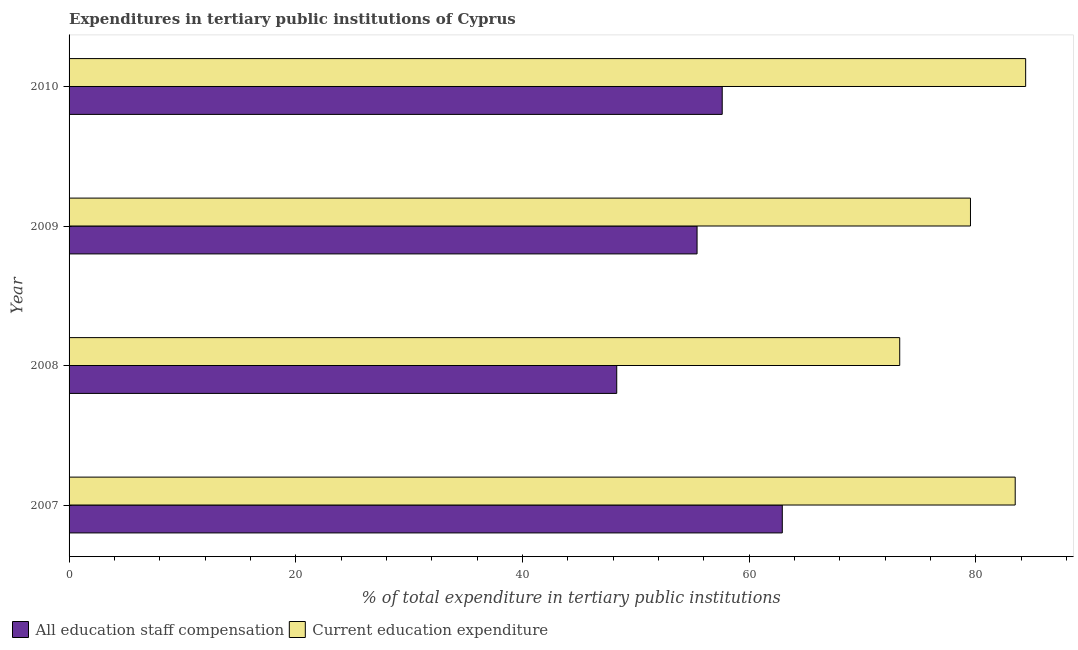How many different coloured bars are there?
Offer a terse response. 2. How many bars are there on the 3rd tick from the bottom?
Make the answer very short. 2. What is the label of the 1st group of bars from the top?
Ensure brevity in your answer.  2010. What is the expenditure in education in 2010?
Keep it short and to the point. 84.39. Across all years, what is the maximum expenditure in education?
Keep it short and to the point. 84.39. Across all years, what is the minimum expenditure in staff compensation?
Make the answer very short. 48.31. In which year was the expenditure in education minimum?
Offer a terse response. 2008. What is the total expenditure in staff compensation in the graph?
Your answer should be compact. 224.26. What is the difference between the expenditure in staff compensation in 2009 and that in 2010?
Your answer should be very brief. -2.22. What is the difference between the expenditure in education in 2008 and the expenditure in staff compensation in 2010?
Your response must be concise. 15.66. What is the average expenditure in staff compensation per year?
Make the answer very short. 56.06. In the year 2007, what is the difference between the expenditure in education and expenditure in staff compensation?
Provide a succinct answer. 20.55. What is the ratio of the expenditure in staff compensation in 2007 to that in 2010?
Offer a terse response. 1.09. Is the expenditure in education in 2008 less than that in 2010?
Your response must be concise. Yes. What is the difference between the highest and the second highest expenditure in staff compensation?
Your answer should be compact. 5.3. What is the difference between the highest and the lowest expenditure in education?
Offer a terse response. 11.11. Is the sum of the expenditure in education in 2009 and 2010 greater than the maximum expenditure in staff compensation across all years?
Your answer should be very brief. Yes. What does the 1st bar from the top in 2010 represents?
Your response must be concise. Current education expenditure. What does the 1st bar from the bottom in 2008 represents?
Offer a terse response. All education staff compensation. How many bars are there?
Your response must be concise. 8. How many years are there in the graph?
Provide a short and direct response. 4. Does the graph contain any zero values?
Provide a short and direct response. No. Does the graph contain grids?
Give a very brief answer. No. Where does the legend appear in the graph?
Give a very brief answer. Bottom left. How many legend labels are there?
Ensure brevity in your answer.  2. What is the title of the graph?
Provide a succinct answer. Expenditures in tertiary public institutions of Cyprus. What is the label or title of the X-axis?
Ensure brevity in your answer.  % of total expenditure in tertiary public institutions. What is the % of total expenditure in tertiary public institutions in All education staff compensation in 2007?
Ensure brevity in your answer.  62.92. What is the % of total expenditure in tertiary public institutions in Current education expenditure in 2007?
Your answer should be very brief. 83.47. What is the % of total expenditure in tertiary public institutions of All education staff compensation in 2008?
Your answer should be compact. 48.31. What is the % of total expenditure in tertiary public institutions in Current education expenditure in 2008?
Your answer should be compact. 73.28. What is the % of total expenditure in tertiary public institutions of All education staff compensation in 2009?
Ensure brevity in your answer.  55.4. What is the % of total expenditure in tertiary public institutions in Current education expenditure in 2009?
Ensure brevity in your answer.  79.52. What is the % of total expenditure in tertiary public institutions in All education staff compensation in 2010?
Your answer should be compact. 57.62. What is the % of total expenditure in tertiary public institutions in Current education expenditure in 2010?
Your response must be concise. 84.39. Across all years, what is the maximum % of total expenditure in tertiary public institutions of All education staff compensation?
Your answer should be very brief. 62.92. Across all years, what is the maximum % of total expenditure in tertiary public institutions of Current education expenditure?
Provide a short and direct response. 84.39. Across all years, what is the minimum % of total expenditure in tertiary public institutions in All education staff compensation?
Give a very brief answer. 48.31. Across all years, what is the minimum % of total expenditure in tertiary public institutions in Current education expenditure?
Your response must be concise. 73.28. What is the total % of total expenditure in tertiary public institutions in All education staff compensation in the graph?
Give a very brief answer. 224.26. What is the total % of total expenditure in tertiary public institutions of Current education expenditure in the graph?
Ensure brevity in your answer.  320.66. What is the difference between the % of total expenditure in tertiary public institutions of All education staff compensation in 2007 and that in 2008?
Provide a short and direct response. 14.61. What is the difference between the % of total expenditure in tertiary public institutions in Current education expenditure in 2007 and that in 2008?
Your response must be concise. 10.19. What is the difference between the % of total expenditure in tertiary public institutions of All education staff compensation in 2007 and that in 2009?
Offer a very short reply. 7.52. What is the difference between the % of total expenditure in tertiary public institutions of Current education expenditure in 2007 and that in 2009?
Your response must be concise. 3.95. What is the difference between the % of total expenditure in tertiary public institutions of All education staff compensation in 2007 and that in 2010?
Your response must be concise. 5.3. What is the difference between the % of total expenditure in tertiary public institutions of Current education expenditure in 2007 and that in 2010?
Your response must be concise. -0.92. What is the difference between the % of total expenditure in tertiary public institutions in All education staff compensation in 2008 and that in 2009?
Make the answer very short. -7.09. What is the difference between the % of total expenditure in tertiary public institutions in Current education expenditure in 2008 and that in 2009?
Provide a short and direct response. -6.24. What is the difference between the % of total expenditure in tertiary public institutions in All education staff compensation in 2008 and that in 2010?
Your response must be concise. -9.31. What is the difference between the % of total expenditure in tertiary public institutions in Current education expenditure in 2008 and that in 2010?
Provide a short and direct response. -11.11. What is the difference between the % of total expenditure in tertiary public institutions in All education staff compensation in 2009 and that in 2010?
Offer a very short reply. -2.22. What is the difference between the % of total expenditure in tertiary public institutions of Current education expenditure in 2009 and that in 2010?
Your answer should be compact. -4.87. What is the difference between the % of total expenditure in tertiary public institutions in All education staff compensation in 2007 and the % of total expenditure in tertiary public institutions in Current education expenditure in 2008?
Make the answer very short. -10.36. What is the difference between the % of total expenditure in tertiary public institutions of All education staff compensation in 2007 and the % of total expenditure in tertiary public institutions of Current education expenditure in 2009?
Keep it short and to the point. -16.6. What is the difference between the % of total expenditure in tertiary public institutions of All education staff compensation in 2007 and the % of total expenditure in tertiary public institutions of Current education expenditure in 2010?
Make the answer very short. -21.47. What is the difference between the % of total expenditure in tertiary public institutions of All education staff compensation in 2008 and the % of total expenditure in tertiary public institutions of Current education expenditure in 2009?
Keep it short and to the point. -31.21. What is the difference between the % of total expenditure in tertiary public institutions in All education staff compensation in 2008 and the % of total expenditure in tertiary public institutions in Current education expenditure in 2010?
Make the answer very short. -36.08. What is the difference between the % of total expenditure in tertiary public institutions in All education staff compensation in 2009 and the % of total expenditure in tertiary public institutions in Current education expenditure in 2010?
Provide a short and direct response. -28.99. What is the average % of total expenditure in tertiary public institutions of All education staff compensation per year?
Ensure brevity in your answer.  56.06. What is the average % of total expenditure in tertiary public institutions of Current education expenditure per year?
Provide a short and direct response. 80.16. In the year 2007, what is the difference between the % of total expenditure in tertiary public institutions of All education staff compensation and % of total expenditure in tertiary public institutions of Current education expenditure?
Offer a very short reply. -20.55. In the year 2008, what is the difference between the % of total expenditure in tertiary public institutions of All education staff compensation and % of total expenditure in tertiary public institutions of Current education expenditure?
Keep it short and to the point. -24.97. In the year 2009, what is the difference between the % of total expenditure in tertiary public institutions of All education staff compensation and % of total expenditure in tertiary public institutions of Current education expenditure?
Your answer should be very brief. -24.12. In the year 2010, what is the difference between the % of total expenditure in tertiary public institutions in All education staff compensation and % of total expenditure in tertiary public institutions in Current education expenditure?
Your response must be concise. -26.77. What is the ratio of the % of total expenditure in tertiary public institutions of All education staff compensation in 2007 to that in 2008?
Your response must be concise. 1.3. What is the ratio of the % of total expenditure in tertiary public institutions of Current education expenditure in 2007 to that in 2008?
Offer a terse response. 1.14. What is the ratio of the % of total expenditure in tertiary public institutions of All education staff compensation in 2007 to that in 2009?
Your answer should be very brief. 1.14. What is the ratio of the % of total expenditure in tertiary public institutions of Current education expenditure in 2007 to that in 2009?
Your answer should be very brief. 1.05. What is the ratio of the % of total expenditure in tertiary public institutions in All education staff compensation in 2007 to that in 2010?
Your response must be concise. 1.09. What is the ratio of the % of total expenditure in tertiary public institutions of All education staff compensation in 2008 to that in 2009?
Make the answer very short. 0.87. What is the ratio of the % of total expenditure in tertiary public institutions of Current education expenditure in 2008 to that in 2009?
Offer a terse response. 0.92. What is the ratio of the % of total expenditure in tertiary public institutions of All education staff compensation in 2008 to that in 2010?
Your answer should be compact. 0.84. What is the ratio of the % of total expenditure in tertiary public institutions in Current education expenditure in 2008 to that in 2010?
Ensure brevity in your answer.  0.87. What is the ratio of the % of total expenditure in tertiary public institutions of All education staff compensation in 2009 to that in 2010?
Your answer should be compact. 0.96. What is the ratio of the % of total expenditure in tertiary public institutions of Current education expenditure in 2009 to that in 2010?
Your answer should be very brief. 0.94. What is the difference between the highest and the second highest % of total expenditure in tertiary public institutions of All education staff compensation?
Keep it short and to the point. 5.3. What is the difference between the highest and the second highest % of total expenditure in tertiary public institutions in Current education expenditure?
Offer a terse response. 0.92. What is the difference between the highest and the lowest % of total expenditure in tertiary public institutions of All education staff compensation?
Your response must be concise. 14.61. What is the difference between the highest and the lowest % of total expenditure in tertiary public institutions of Current education expenditure?
Provide a succinct answer. 11.11. 